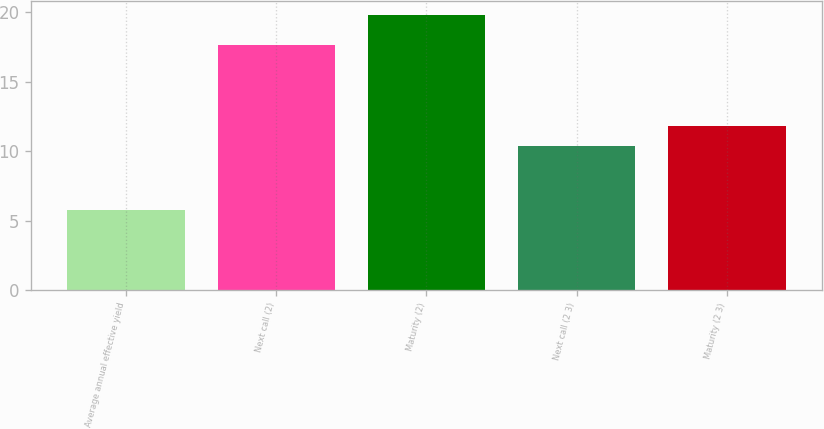<chart> <loc_0><loc_0><loc_500><loc_500><bar_chart><fcel>Average annual effective yield<fcel>Next call (2)<fcel>Maturity (2)<fcel>Next call (2 3)<fcel>Maturity (2 3)<nl><fcel>5.74<fcel>17.6<fcel>19.8<fcel>10.4<fcel>11.81<nl></chart> 